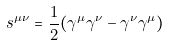Convert formula to latex. <formula><loc_0><loc_0><loc_500><loc_500>s ^ { \mu \nu } = \frac { 1 } { 2 } ( \gamma ^ { \mu } \gamma ^ { \nu } - \gamma ^ { \nu } \gamma ^ { \mu } )</formula> 